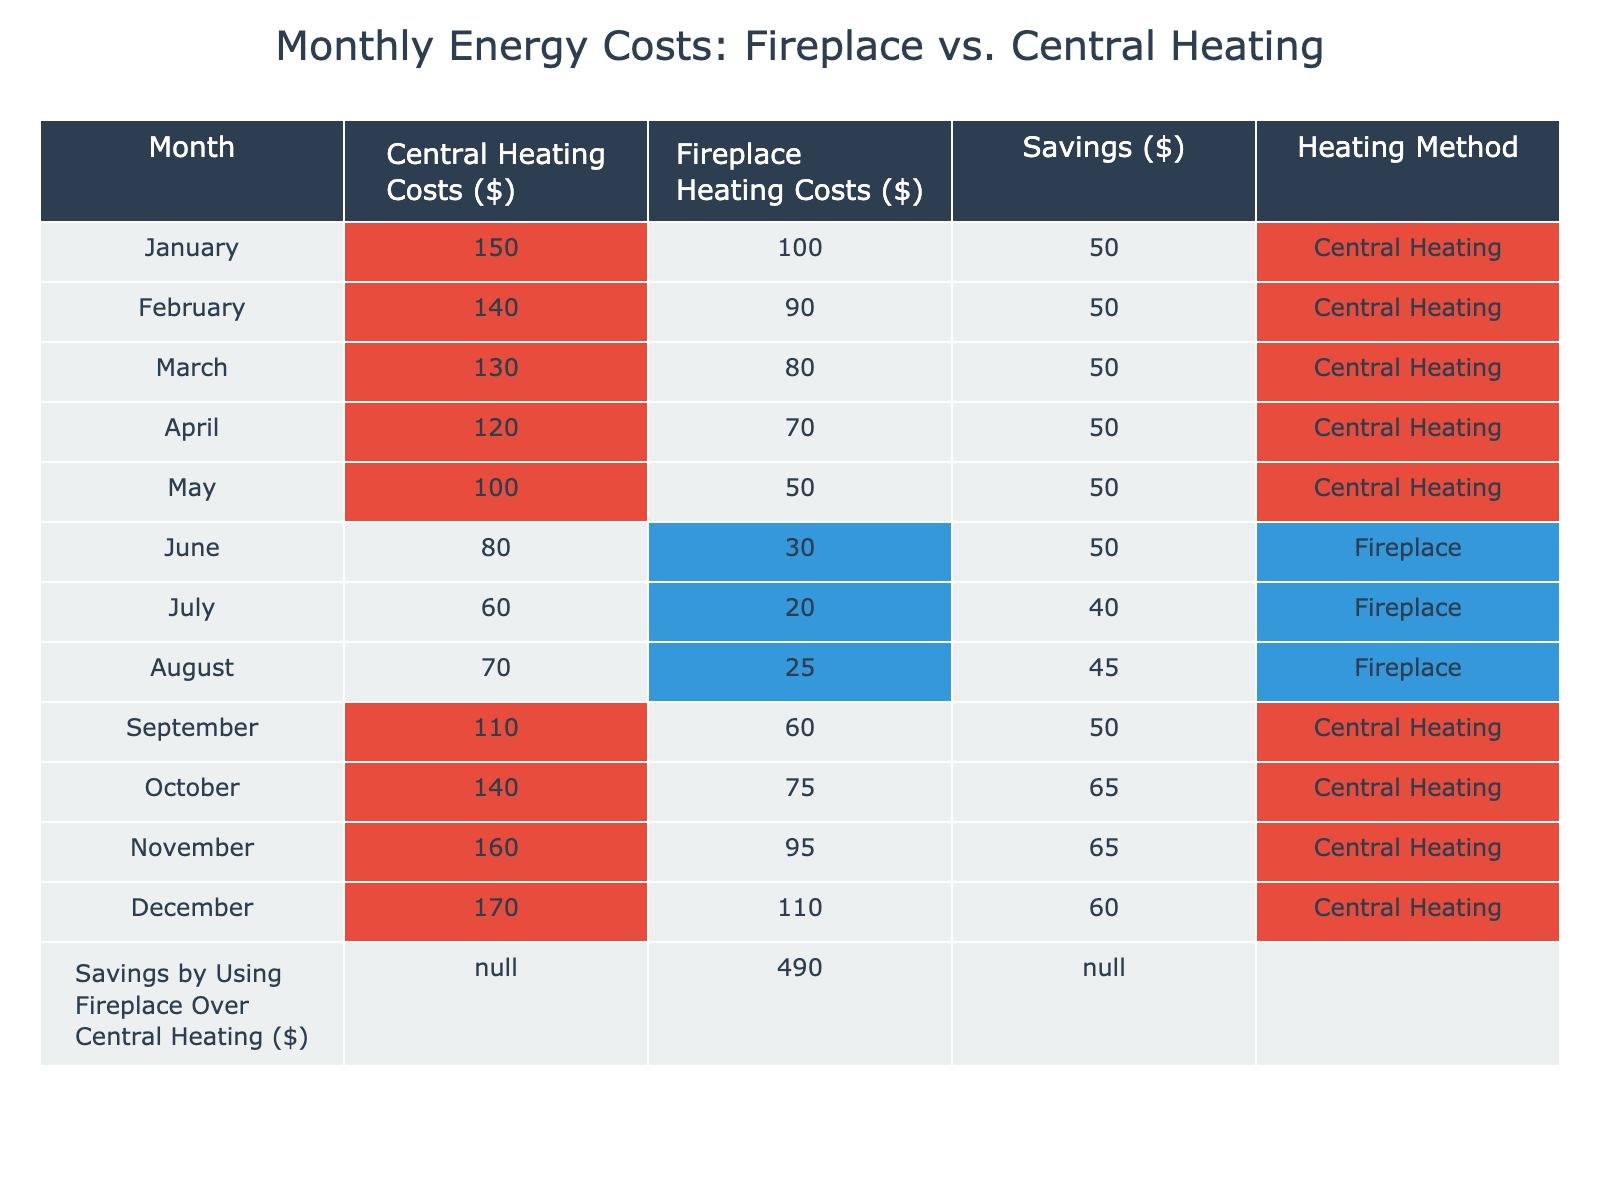What are the Central Heating Costs for December? Looking at the column for Central Heating Costs, the value for December is 170 dollars.
Answer: 170 What is the total amount saved by using a Fireplace instead of Central Heating over the entire year? The table shows the total savings by using a Fireplace is 490 dollars, which is explicitly stated at the bottom.
Answer: 490 In which month are the Central Heating Costs the highest? By checking each month in the Central Heating Costs column, December has the highest value at 170 dollars.
Answer: December During which month is the difference in costs between Central Heating and Fireplace Heating the largest? Calculating the differences for each month, the largest difference occurs in December, where Central Heating costs 170 dollars and Fireplace costs 110 dollars. The difference is 60 dollars.
Answer: December What is the average cost of using a Fireplace for Heating over the 12 months? Adding all the costs for the Fireplace and dividing by the number of months (12) gives an average of (100 + 90 + 80 + 70 + 50 + 30 + 20 + 25 + 60 + 75 + 95 + 110) = 70.42 dollars. So, 70.42 / 12 = 70.42.
Answer: 70.42 Is it cheaper to use a Fireplace rather than Central Heating in the summer months? Looking at the summer months (June, July, August), Fireplace costs are 30, 20, and 25 dollars while Central Heating costs are 80, 60, and 70 dollars, respectively. Therefore, it is cheaper to use the Fireplace in the summer months.
Answer: Yes What months indicate when Central Heating costs are consistently more than Fireplace costs? By analyzing the data, the months from January to May show Central Heating costs always being higher than Fireplace costs.
Answer: January to May In which month does the cost of Fireplace Heating first drop below 40 dollars? Reviewing the Fireplace Heating Costs, the first month where the cost drops below 40 dollars is July at 20 dollars.
Answer: July What is the total cost of Central Heating from January to April? Summing the values for Central Heating costs in January (150), February (140), March (130), and April (120) gives 150 + 140 + 130 + 120 = 540 dollars.
Answer: 540 How much does it cost to heat with the Fireplace in March? Looking directly at the Fireplace Heating Costs column, the cost for March is 80 dollars.
Answer: 80 